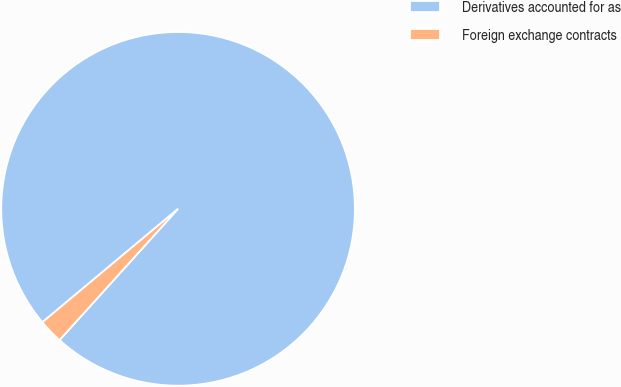Convert chart to OTSL. <chart><loc_0><loc_0><loc_500><loc_500><pie_chart><fcel>Derivatives accounted for as<fcel>Foreign exchange contracts<nl><fcel>97.77%<fcel>2.23%<nl></chart> 